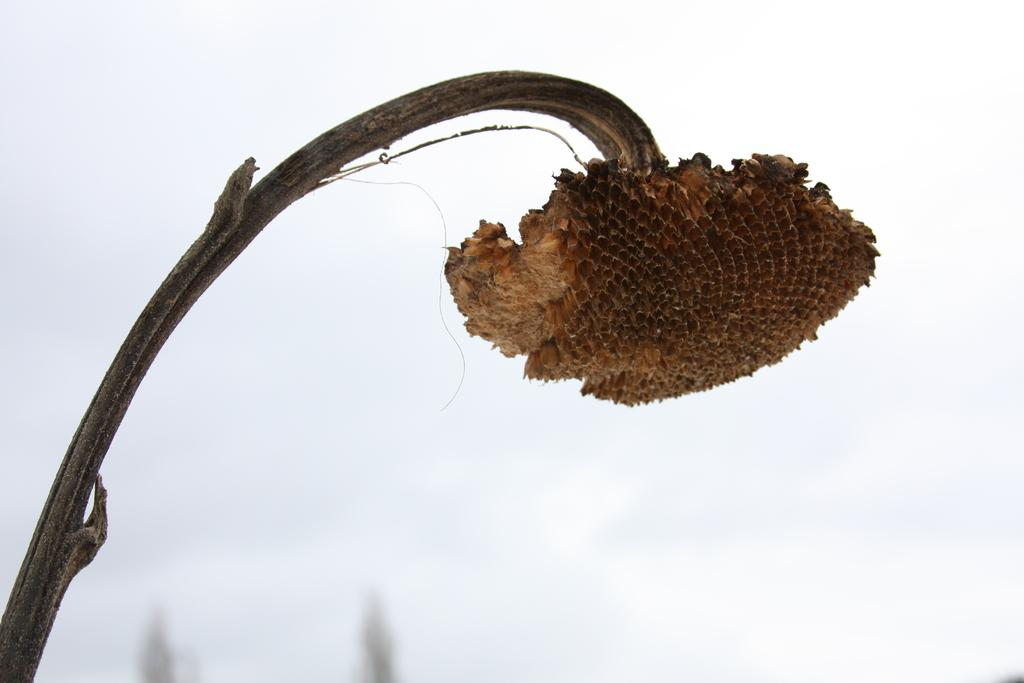What is the main subject in the center of the image? There is an object that resembles a honeycomb in the center of the image. How is the honeycomb-like object positioned in the image? The honeycomb-like object is hanging on an object that appears to be a tree branch. What can be seen in the background of the image? The sky is visible in the background of the image. What type of scent can be detected from the honeycomb in the image? There is no indication of scent in the image, as it is a visual representation. 